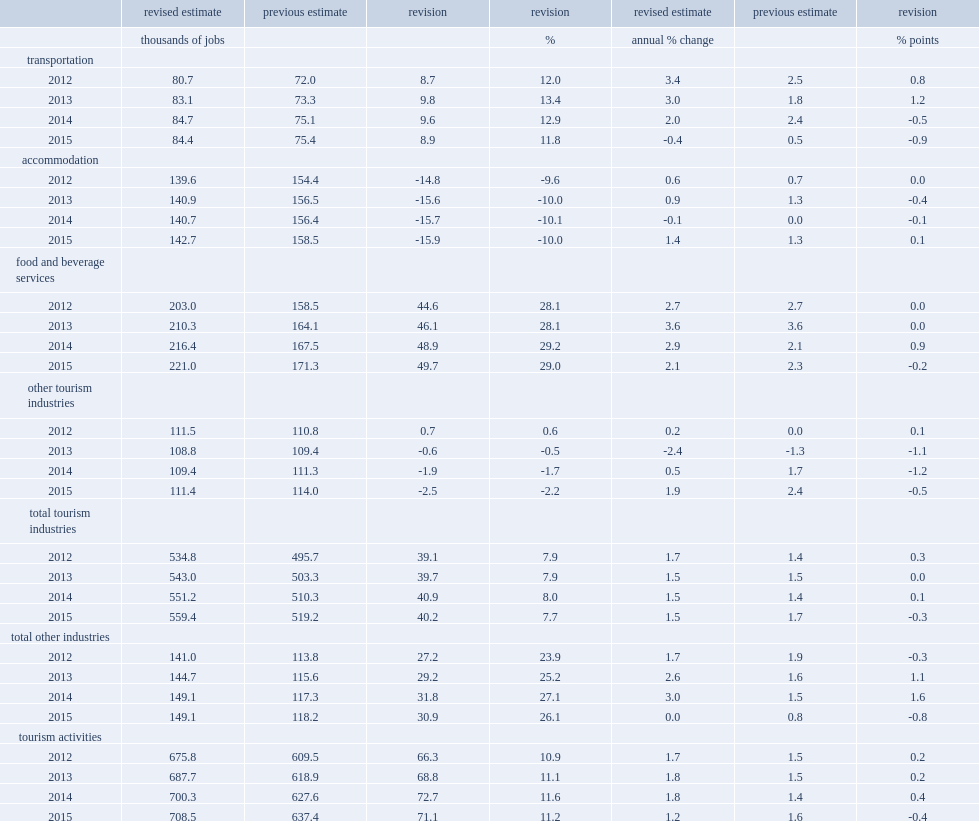What was the percent of tourism employment revised up? 11.2. How many jobs were tourism employment revised up in 2015? 708.5. 